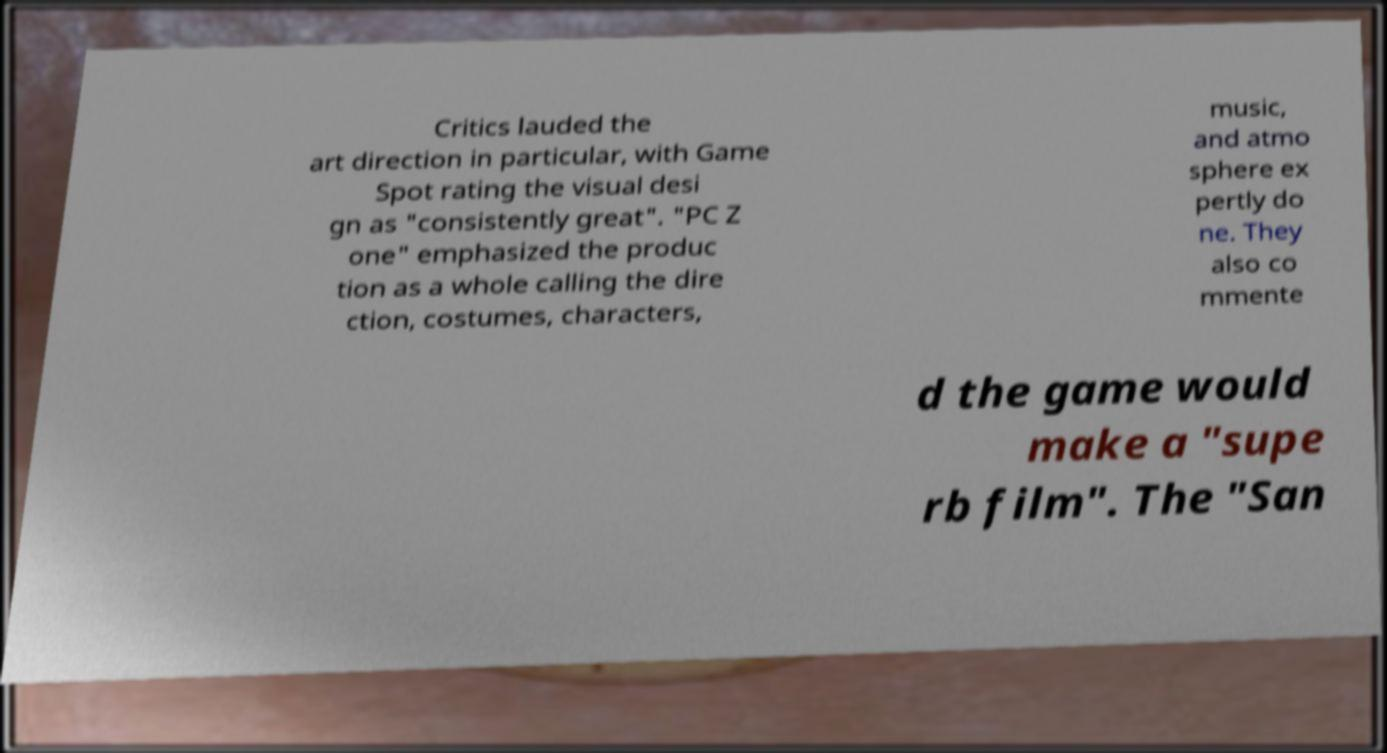Can you read and provide the text displayed in the image?This photo seems to have some interesting text. Can you extract and type it out for me? Critics lauded the art direction in particular, with Game Spot rating the visual desi gn as "consistently great". "PC Z one" emphasized the produc tion as a whole calling the dire ction, costumes, characters, music, and atmo sphere ex pertly do ne. They also co mmente d the game would make a "supe rb film". The "San 